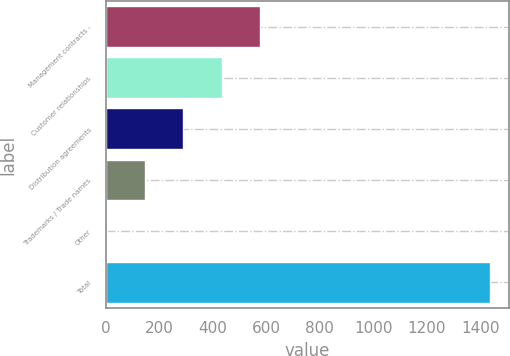Convert chart. <chart><loc_0><loc_0><loc_500><loc_500><bar_chart><fcel>Management contracts -<fcel>Customer relationships<fcel>Distribution agreements<fcel>Trademarks / Trade names<fcel>Other<fcel>Total<nl><fcel>576.16<fcel>433.02<fcel>289.88<fcel>146.74<fcel>3.6<fcel>1435<nl></chart> 